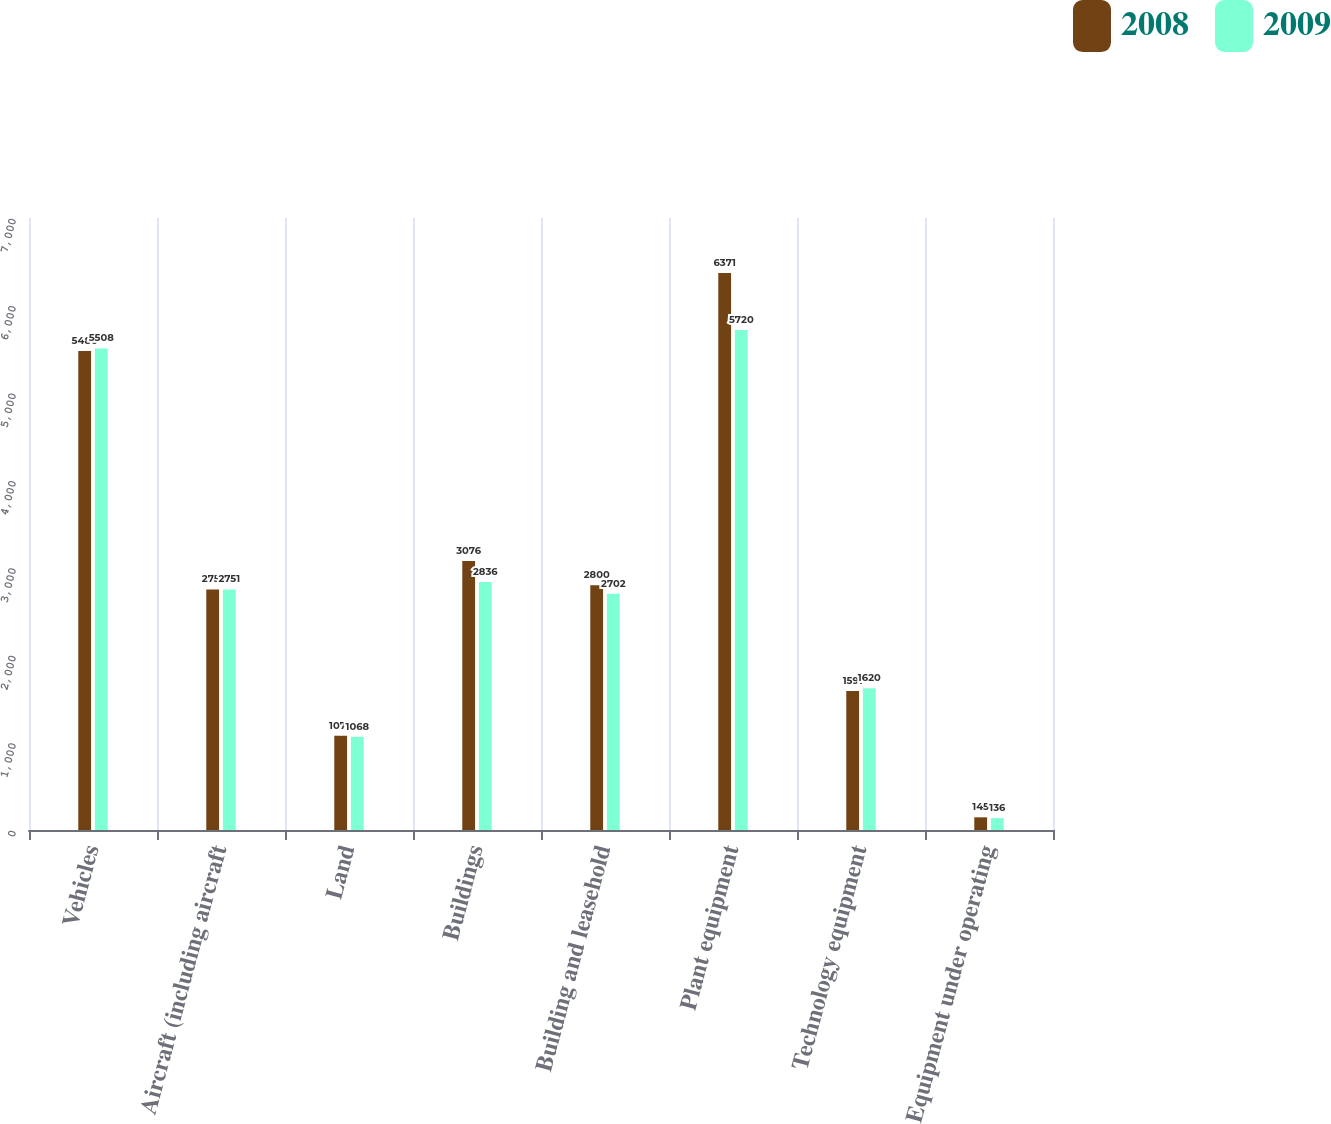Convert chart to OTSL. <chart><loc_0><loc_0><loc_500><loc_500><stacked_bar_chart><ecel><fcel>Vehicles<fcel>Aircraft (including aircraft<fcel>Land<fcel>Buildings<fcel>Building and leasehold<fcel>Plant equipment<fcel>Technology equipment<fcel>Equipment under operating<nl><fcel>2008<fcel>5480<fcel>2751<fcel>1079<fcel>3076<fcel>2800<fcel>6371<fcel>1591<fcel>145<nl><fcel>2009<fcel>5508<fcel>2751<fcel>1068<fcel>2836<fcel>2702<fcel>5720<fcel>1620<fcel>136<nl></chart> 